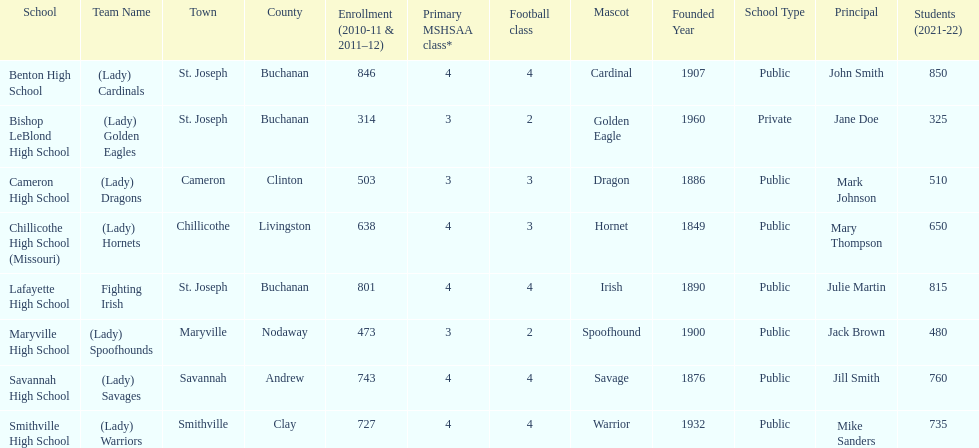Which schools are in the same town as bishop leblond? Benton High School, Lafayette High School. 